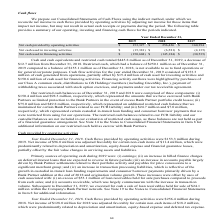From Greensky's financial document, Which years does the table provide information for the company's cash flows? The document contains multiple relevant values: 2019, 2018, 2017. From the document: "Year Ended December 31, 2019 2018 2017 Year Ended December 31, 2019 2018 2017 Year Ended December 31, 2019 2018 2017..." Also, What was the Net cash used in investing activities in 2019? According to the financial document, (15,381) (in thousands). The relevant text states: "Net cash used in investing activities $ (15,381) $ (6,581) $ (4,135)..." Also, What was the Net cash provided by operating activities in 2017? According to the financial document, 160,394 (in thousands). The relevant text states: "ded by operating activities $ 153,327 $ 256,426 $ 160,394..." Also, How many years did the Net cash provided by operating activities exceed $200,000 thousand? Based on the analysis, there are 1 instances. The counting process: 2018. Also, can you calculate: What was the change in the Net cash used in investing activities between 2017 and 2019? Based on the calculation: -15,381-(-4,135), the result is -11246 (in thousands). This is based on the information: "d in investing activities $ (15,381) $ (6,581) $ (4,135) Net cash used in investing activities $ (15,381) $ (6,581) $ (4,135)..." The key data points involved are: 15,381, 4,135. Also, can you calculate: What was the percentage change in the Net cash used in financing activities between 2018 and 2019? To answer this question, I need to perform calculations using the financial data. The calculation is: (-150,604-(-145,184))/-145,184, which equals 3.73 (percentage). This is based on the information: "cash used in financing activities $ (150,604) $ (145,184) $ (30,535) Net cash used in financing activities $ (150,604) $ (145,184) $ (30,535)..." The key data points involved are: 145,184, 150,604. 